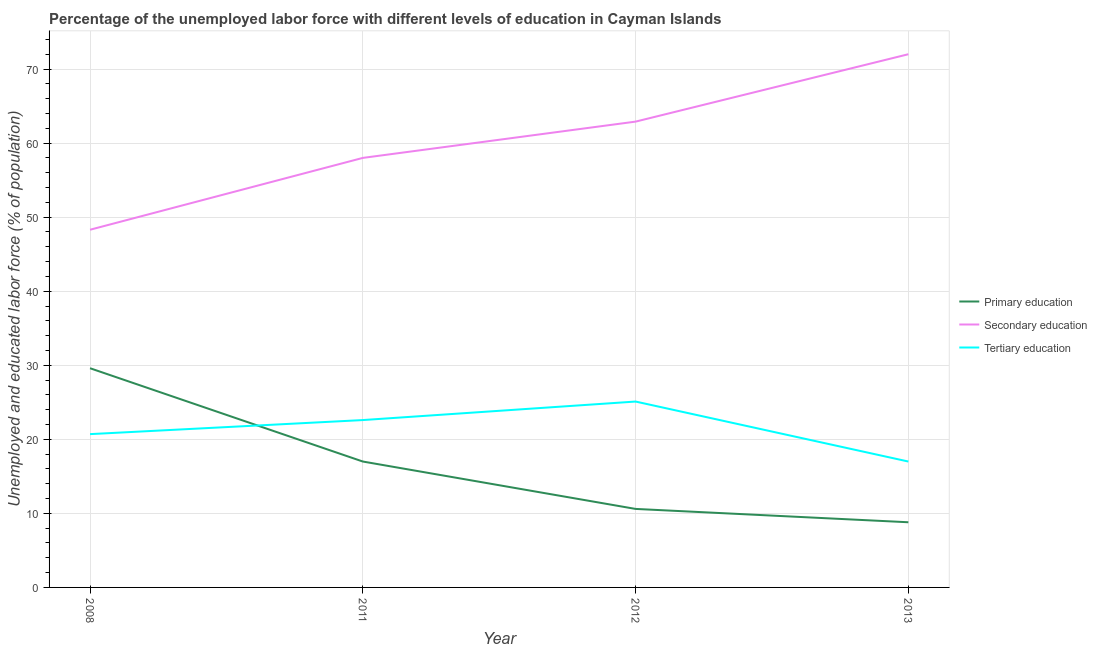How many different coloured lines are there?
Give a very brief answer. 3. Does the line corresponding to percentage of labor force who received tertiary education intersect with the line corresponding to percentage of labor force who received secondary education?
Your answer should be compact. No. Is the number of lines equal to the number of legend labels?
Offer a very short reply. Yes. What is the percentage of labor force who received tertiary education in 2013?
Keep it short and to the point. 17. Across all years, what is the maximum percentage of labor force who received tertiary education?
Your response must be concise. 25.1. Across all years, what is the minimum percentage of labor force who received primary education?
Keep it short and to the point. 8.8. What is the total percentage of labor force who received tertiary education in the graph?
Keep it short and to the point. 85.4. What is the difference between the percentage of labor force who received secondary education in 2011 and that in 2013?
Your response must be concise. -14. What is the difference between the percentage of labor force who received primary education in 2012 and the percentage of labor force who received secondary education in 2008?
Your answer should be compact. -37.7. What is the average percentage of labor force who received primary education per year?
Ensure brevity in your answer.  16.5. In the year 2011, what is the difference between the percentage of labor force who received tertiary education and percentage of labor force who received secondary education?
Keep it short and to the point. -35.4. What is the ratio of the percentage of labor force who received tertiary education in 2011 to that in 2012?
Provide a short and direct response. 0.9. What is the difference between the highest and the lowest percentage of labor force who received secondary education?
Offer a terse response. 23.7. In how many years, is the percentage of labor force who received secondary education greater than the average percentage of labor force who received secondary education taken over all years?
Give a very brief answer. 2. Is it the case that in every year, the sum of the percentage of labor force who received primary education and percentage of labor force who received secondary education is greater than the percentage of labor force who received tertiary education?
Provide a succinct answer. Yes. Is the percentage of labor force who received primary education strictly less than the percentage of labor force who received secondary education over the years?
Your response must be concise. Yes. Are the values on the major ticks of Y-axis written in scientific E-notation?
Your answer should be very brief. No. Does the graph contain any zero values?
Provide a short and direct response. No. How are the legend labels stacked?
Provide a short and direct response. Vertical. What is the title of the graph?
Keep it short and to the point. Percentage of the unemployed labor force with different levels of education in Cayman Islands. What is the label or title of the X-axis?
Provide a succinct answer. Year. What is the label or title of the Y-axis?
Your answer should be compact. Unemployed and educated labor force (% of population). What is the Unemployed and educated labor force (% of population) of Primary education in 2008?
Give a very brief answer. 29.6. What is the Unemployed and educated labor force (% of population) in Secondary education in 2008?
Keep it short and to the point. 48.3. What is the Unemployed and educated labor force (% of population) of Tertiary education in 2008?
Provide a short and direct response. 20.7. What is the Unemployed and educated labor force (% of population) in Secondary education in 2011?
Your answer should be compact. 58. What is the Unemployed and educated labor force (% of population) of Tertiary education in 2011?
Your answer should be very brief. 22.6. What is the Unemployed and educated labor force (% of population) of Primary education in 2012?
Your answer should be compact. 10.6. What is the Unemployed and educated labor force (% of population) in Secondary education in 2012?
Give a very brief answer. 62.9. What is the Unemployed and educated labor force (% of population) in Tertiary education in 2012?
Give a very brief answer. 25.1. What is the Unemployed and educated labor force (% of population) of Primary education in 2013?
Give a very brief answer. 8.8. What is the Unemployed and educated labor force (% of population) in Tertiary education in 2013?
Give a very brief answer. 17. Across all years, what is the maximum Unemployed and educated labor force (% of population) in Primary education?
Provide a succinct answer. 29.6. Across all years, what is the maximum Unemployed and educated labor force (% of population) of Secondary education?
Provide a short and direct response. 72. Across all years, what is the maximum Unemployed and educated labor force (% of population) of Tertiary education?
Offer a very short reply. 25.1. Across all years, what is the minimum Unemployed and educated labor force (% of population) in Primary education?
Ensure brevity in your answer.  8.8. Across all years, what is the minimum Unemployed and educated labor force (% of population) of Secondary education?
Your answer should be very brief. 48.3. Across all years, what is the minimum Unemployed and educated labor force (% of population) in Tertiary education?
Provide a short and direct response. 17. What is the total Unemployed and educated labor force (% of population) of Primary education in the graph?
Offer a very short reply. 66. What is the total Unemployed and educated labor force (% of population) of Secondary education in the graph?
Ensure brevity in your answer.  241.2. What is the total Unemployed and educated labor force (% of population) of Tertiary education in the graph?
Your answer should be compact. 85.4. What is the difference between the Unemployed and educated labor force (% of population) of Primary education in 2008 and that in 2011?
Offer a very short reply. 12.6. What is the difference between the Unemployed and educated labor force (% of population) of Primary education in 2008 and that in 2012?
Keep it short and to the point. 19. What is the difference between the Unemployed and educated labor force (% of population) in Secondary education in 2008 and that in 2012?
Keep it short and to the point. -14.6. What is the difference between the Unemployed and educated labor force (% of population) in Primary education in 2008 and that in 2013?
Provide a short and direct response. 20.8. What is the difference between the Unemployed and educated labor force (% of population) in Secondary education in 2008 and that in 2013?
Your answer should be very brief. -23.7. What is the difference between the Unemployed and educated labor force (% of population) of Tertiary education in 2008 and that in 2013?
Offer a very short reply. 3.7. What is the difference between the Unemployed and educated labor force (% of population) in Primary education in 2011 and that in 2012?
Your response must be concise. 6.4. What is the difference between the Unemployed and educated labor force (% of population) of Primary education in 2012 and that in 2013?
Keep it short and to the point. 1.8. What is the difference between the Unemployed and educated labor force (% of population) of Secondary education in 2012 and that in 2013?
Your answer should be very brief. -9.1. What is the difference between the Unemployed and educated labor force (% of population) of Tertiary education in 2012 and that in 2013?
Your answer should be compact. 8.1. What is the difference between the Unemployed and educated labor force (% of population) of Primary education in 2008 and the Unemployed and educated labor force (% of population) of Secondary education in 2011?
Provide a short and direct response. -28.4. What is the difference between the Unemployed and educated labor force (% of population) of Primary education in 2008 and the Unemployed and educated labor force (% of population) of Tertiary education in 2011?
Keep it short and to the point. 7. What is the difference between the Unemployed and educated labor force (% of population) in Secondary education in 2008 and the Unemployed and educated labor force (% of population) in Tertiary education in 2011?
Provide a short and direct response. 25.7. What is the difference between the Unemployed and educated labor force (% of population) of Primary education in 2008 and the Unemployed and educated labor force (% of population) of Secondary education in 2012?
Ensure brevity in your answer.  -33.3. What is the difference between the Unemployed and educated labor force (% of population) of Primary education in 2008 and the Unemployed and educated labor force (% of population) of Tertiary education in 2012?
Your answer should be compact. 4.5. What is the difference between the Unemployed and educated labor force (% of population) in Secondary education in 2008 and the Unemployed and educated labor force (% of population) in Tertiary education in 2012?
Your answer should be compact. 23.2. What is the difference between the Unemployed and educated labor force (% of population) of Primary education in 2008 and the Unemployed and educated labor force (% of population) of Secondary education in 2013?
Offer a terse response. -42.4. What is the difference between the Unemployed and educated labor force (% of population) of Primary education in 2008 and the Unemployed and educated labor force (% of population) of Tertiary education in 2013?
Provide a succinct answer. 12.6. What is the difference between the Unemployed and educated labor force (% of population) in Secondary education in 2008 and the Unemployed and educated labor force (% of population) in Tertiary education in 2013?
Offer a terse response. 31.3. What is the difference between the Unemployed and educated labor force (% of population) in Primary education in 2011 and the Unemployed and educated labor force (% of population) in Secondary education in 2012?
Ensure brevity in your answer.  -45.9. What is the difference between the Unemployed and educated labor force (% of population) in Secondary education in 2011 and the Unemployed and educated labor force (% of population) in Tertiary education in 2012?
Your response must be concise. 32.9. What is the difference between the Unemployed and educated labor force (% of population) of Primary education in 2011 and the Unemployed and educated labor force (% of population) of Secondary education in 2013?
Ensure brevity in your answer.  -55. What is the difference between the Unemployed and educated labor force (% of population) in Primary education in 2011 and the Unemployed and educated labor force (% of population) in Tertiary education in 2013?
Give a very brief answer. 0. What is the difference between the Unemployed and educated labor force (% of population) of Secondary education in 2011 and the Unemployed and educated labor force (% of population) of Tertiary education in 2013?
Keep it short and to the point. 41. What is the difference between the Unemployed and educated labor force (% of population) of Primary education in 2012 and the Unemployed and educated labor force (% of population) of Secondary education in 2013?
Offer a terse response. -61.4. What is the difference between the Unemployed and educated labor force (% of population) in Secondary education in 2012 and the Unemployed and educated labor force (% of population) in Tertiary education in 2013?
Provide a short and direct response. 45.9. What is the average Unemployed and educated labor force (% of population) in Primary education per year?
Your answer should be very brief. 16.5. What is the average Unemployed and educated labor force (% of population) of Secondary education per year?
Provide a short and direct response. 60.3. What is the average Unemployed and educated labor force (% of population) in Tertiary education per year?
Make the answer very short. 21.35. In the year 2008, what is the difference between the Unemployed and educated labor force (% of population) in Primary education and Unemployed and educated labor force (% of population) in Secondary education?
Keep it short and to the point. -18.7. In the year 2008, what is the difference between the Unemployed and educated labor force (% of population) in Primary education and Unemployed and educated labor force (% of population) in Tertiary education?
Give a very brief answer. 8.9. In the year 2008, what is the difference between the Unemployed and educated labor force (% of population) of Secondary education and Unemployed and educated labor force (% of population) of Tertiary education?
Offer a terse response. 27.6. In the year 2011, what is the difference between the Unemployed and educated labor force (% of population) in Primary education and Unemployed and educated labor force (% of population) in Secondary education?
Give a very brief answer. -41. In the year 2011, what is the difference between the Unemployed and educated labor force (% of population) in Secondary education and Unemployed and educated labor force (% of population) in Tertiary education?
Provide a short and direct response. 35.4. In the year 2012, what is the difference between the Unemployed and educated labor force (% of population) in Primary education and Unemployed and educated labor force (% of population) in Secondary education?
Ensure brevity in your answer.  -52.3. In the year 2012, what is the difference between the Unemployed and educated labor force (% of population) in Primary education and Unemployed and educated labor force (% of population) in Tertiary education?
Provide a succinct answer. -14.5. In the year 2012, what is the difference between the Unemployed and educated labor force (% of population) of Secondary education and Unemployed and educated labor force (% of population) of Tertiary education?
Your response must be concise. 37.8. In the year 2013, what is the difference between the Unemployed and educated labor force (% of population) in Primary education and Unemployed and educated labor force (% of population) in Secondary education?
Ensure brevity in your answer.  -63.2. In the year 2013, what is the difference between the Unemployed and educated labor force (% of population) in Primary education and Unemployed and educated labor force (% of population) in Tertiary education?
Ensure brevity in your answer.  -8.2. In the year 2013, what is the difference between the Unemployed and educated labor force (% of population) of Secondary education and Unemployed and educated labor force (% of population) of Tertiary education?
Offer a very short reply. 55. What is the ratio of the Unemployed and educated labor force (% of population) of Primary education in 2008 to that in 2011?
Your response must be concise. 1.74. What is the ratio of the Unemployed and educated labor force (% of population) in Secondary education in 2008 to that in 2011?
Your answer should be very brief. 0.83. What is the ratio of the Unemployed and educated labor force (% of population) in Tertiary education in 2008 to that in 2011?
Your answer should be compact. 0.92. What is the ratio of the Unemployed and educated labor force (% of population) in Primary education in 2008 to that in 2012?
Your response must be concise. 2.79. What is the ratio of the Unemployed and educated labor force (% of population) in Secondary education in 2008 to that in 2012?
Make the answer very short. 0.77. What is the ratio of the Unemployed and educated labor force (% of population) of Tertiary education in 2008 to that in 2012?
Your answer should be very brief. 0.82. What is the ratio of the Unemployed and educated labor force (% of population) of Primary education in 2008 to that in 2013?
Your response must be concise. 3.36. What is the ratio of the Unemployed and educated labor force (% of population) of Secondary education in 2008 to that in 2013?
Provide a short and direct response. 0.67. What is the ratio of the Unemployed and educated labor force (% of population) of Tertiary education in 2008 to that in 2013?
Provide a short and direct response. 1.22. What is the ratio of the Unemployed and educated labor force (% of population) in Primary education in 2011 to that in 2012?
Provide a succinct answer. 1.6. What is the ratio of the Unemployed and educated labor force (% of population) in Secondary education in 2011 to that in 2012?
Offer a very short reply. 0.92. What is the ratio of the Unemployed and educated labor force (% of population) in Tertiary education in 2011 to that in 2012?
Offer a terse response. 0.9. What is the ratio of the Unemployed and educated labor force (% of population) in Primary education in 2011 to that in 2013?
Make the answer very short. 1.93. What is the ratio of the Unemployed and educated labor force (% of population) in Secondary education in 2011 to that in 2013?
Your answer should be very brief. 0.81. What is the ratio of the Unemployed and educated labor force (% of population) in Tertiary education in 2011 to that in 2013?
Keep it short and to the point. 1.33. What is the ratio of the Unemployed and educated labor force (% of population) of Primary education in 2012 to that in 2013?
Provide a short and direct response. 1.2. What is the ratio of the Unemployed and educated labor force (% of population) in Secondary education in 2012 to that in 2013?
Provide a succinct answer. 0.87. What is the ratio of the Unemployed and educated labor force (% of population) of Tertiary education in 2012 to that in 2013?
Make the answer very short. 1.48. What is the difference between the highest and the lowest Unemployed and educated labor force (% of population) in Primary education?
Ensure brevity in your answer.  20.8. What is the difference between the highest and the lowest Unemployed and educated labor force (% of population) in Secondary education?
Keep it short and to the point. 23.7. 